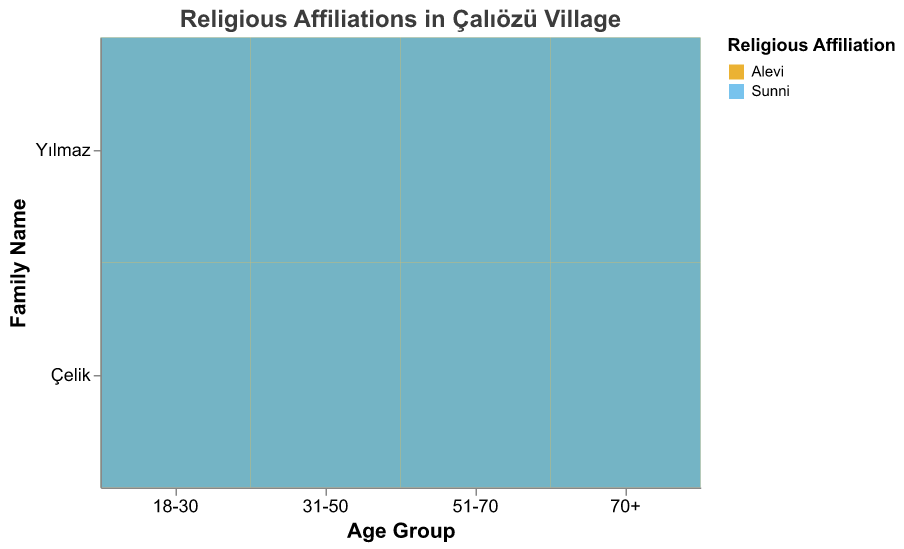What is the title of the plot? The title is usually placed at the top of the plot, and it describes the overall theme or subject of the visualization.
Answer: Religious Affiliations in Çalıözü Village How many age groups are represented in the plot? Look at the x-axis labeled "Age Group," which typically denotes the different categories or groups.
Answer: 4 Which family name has the most Alevi members in the 51-70 age group? Find the "51-70" age group on the x-axis, look for the family names in this group, and identify the one with the largest Alevi count.
Answer: Yılmaz What is the total number of Sunni members in the 18-30 age group? Focus on the age group "18-30," sum the counts of Sunni members from both Yılmaz and Çelik families.
Answer: 5 How do Alevi and Sunni distributions compare in the 31-50 age group? For the age group "31-50," compare the size and coloration indicating Alevi and Sunni affiliations across both Yılmaz and Çelik families.
Answer: More Alevi than Sunni What is the difference in the number of Alevi and Sunni members in the Yılmaz family for the 70+ age group? Look at the 70+ age group for the Yılmaz family, identify counts for Alevi and Sunni, and calculate the difference.
Answer: 6 (7 Alevi - 1 Sunni) Which religious affiliation has a larger representation across all age groups? Sum the counts of both Alevi and Sunni members across all age groups and identify the larger sum.
Answer: Alevi In which age group does the Çelik family have the least number of Sunni members? Identify the count of Sunni members for the Çelik family in each age group and find the one with the minimum.
Answer: 51-70 How do the religious affiliations in the 31-50 and 51-70 age groups for the Çelik family compare? Compare counts of both Alevi and Sunni members in the Çelik family within the 31-50 and 51-70 age groups.
Answer: More Alevi and less Sunni in 51-70 How does the plot represent family names and religious affiliations? Observe the plot's encoding to understand how colors, axes, and sizes visually denote family names and religious affiliations.
Answer: Family names on y-axis, religious affiliations by color, sizes by count 